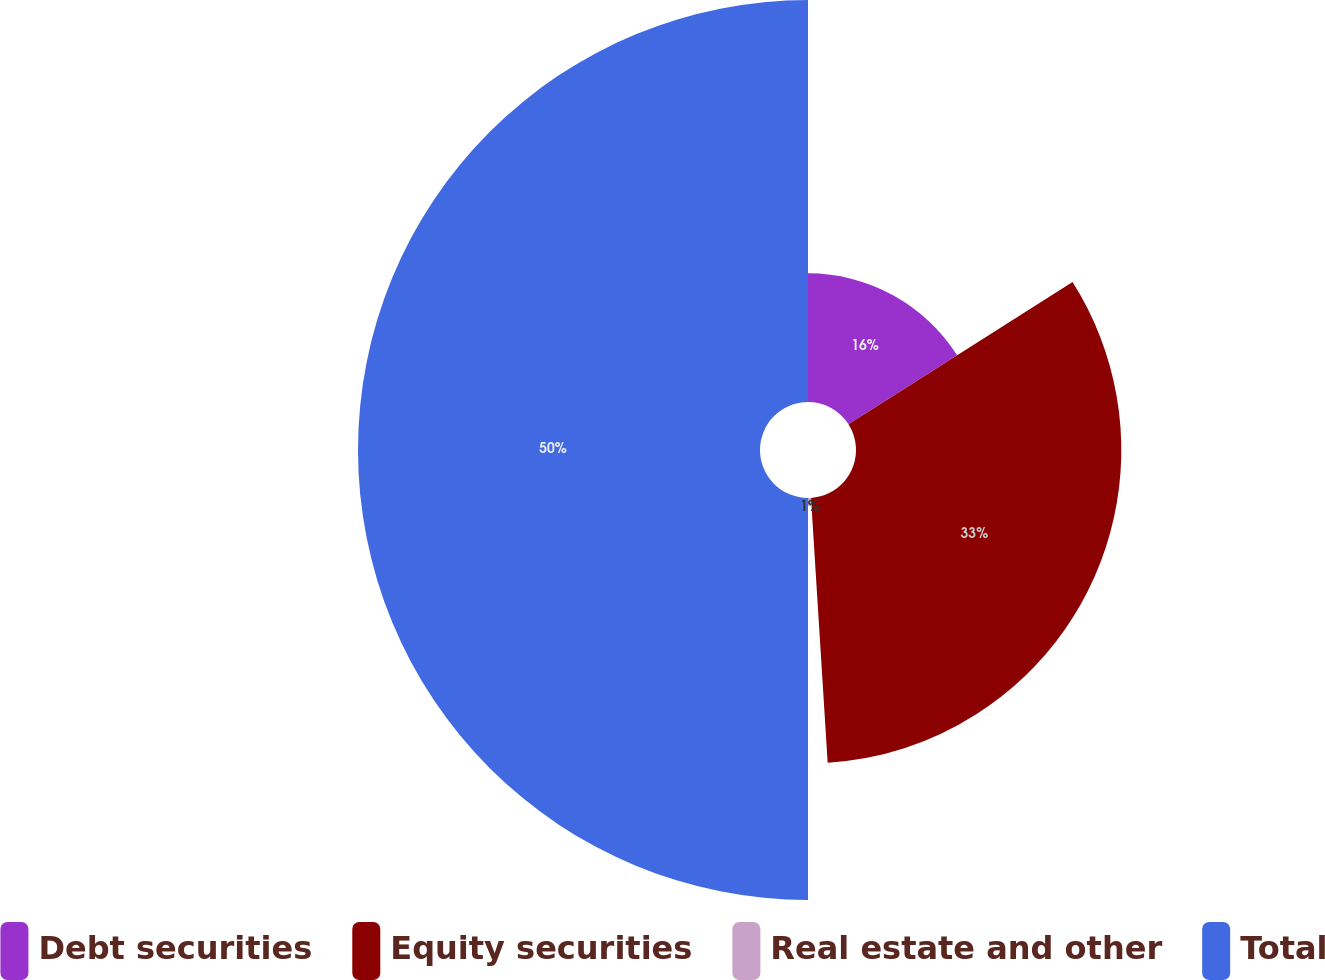Convert chart to OTSL. <chart><loc_0><loc_0><loc_500><loc_500><pie_chart><fcel>Debt securities<fcel>Equity securities<fcel>Real estate and other<fcel>Total<nl><fcel>16.0%<fcel>33.0%<fcel>1.0%<fcel>50.0%<nl></chart> 